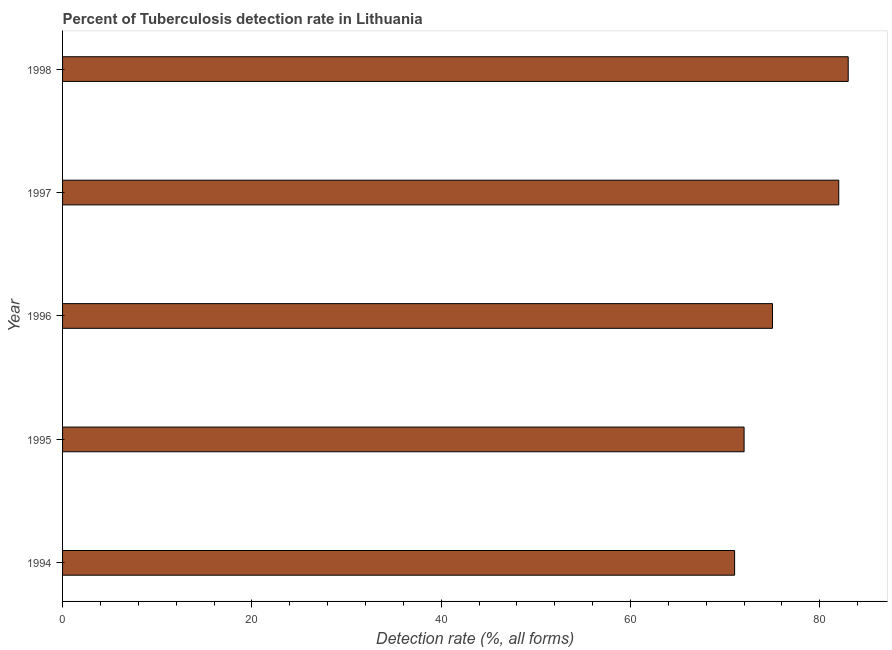Does the graph contain any zero values?
Keep it short and to the point. No. What is the title of the graph?
Your answer should be compact. Percent of Tuberculosis detection rate in Lithuania. What is the label or title of the X-axis?
Provide a succinct answer. Detection rate (%, all forms). What is the label or title of the Y-axis?
Ensure brevity in your answer.  Year. What is the detection rate of tuberculosis in 1996?
Ensure brevity in your answer.  75. Across all years, what is the minimum detection rate of tuberculosis?
Offer a terse response. 71. What is the sum of the detection rate of tuberculosis?
Make the answer very short. 383. What is the difference between the detection rate of tuberculosis in 1994 and 1996?
Your answer should be compact. -4. What is the average detection rate of tuberculosis per year?
Provide a short and direct response. 76. What is the median detection rate of tuberculosis?
Make the answer very short. 75. In how many years, is the detection rate of tuberculosis greater than 32 %?
Provide a short and direct response. 5. What is the ratio of the detection rate of tuberculosis in 1994 to that in 1998?
Your answer should be compact. 0.85. Is the detection rate of tuberculosis in 1994 less than that in 1998?
Your response must be concise. Yes. Is the difference between the detection rate of tuberculosis in 1995 and 1997 greater than the difference between any two years?
Provide a succinct answer. No. What is the difference between the highest and the second highest detection rate of tuberculosis?
Keep it short and to the point. 1. What is the difference between the highest and the lowest detection rate of tuberculosis?
Your answer should be very brief. 12. How many bars are there?
Provide a short and direct response. 5. What is the Detection rate (%, all forms) in 1994?
Make the answer very short. 71. What is the Detection rate (%, all forms) of 1996?
Offer a terse response. 75. What is the difference between the Detection rate (%, all forms) in 1994 and 1996?
Keep it short and to the point. -4. What is the difference between the Detection rate (%, all forms) in 1995 and 1996?
Your response must be concise. -3. What is the difference between the Detection rate (%, all forms) in 1995 and 1997?
Offer a terse response. -10. What is the difference between the Detection rate (%, all forms) in 1995 and 1998?
Keep it short and to the point. -11. What is the difference between the Detection rate (%, all forms) in 1996 and 1997?
Offer a very short reply. -7. What is the difference between the Detection rate (%, all forms) in 1996 and 1998?
Keep it short and to the point. -8. What is the ratio of the Detection rate (%, all forms) in 1994 to that in 1996?
Provide a short and direct response. 0.95. What is the ratio of the Detection rate (%, all forms) in 1994 to that in 1997?
Your answer should be compact. 0.87. What is the ratio of the Detection rate (%, all forms) in 1994 to that in 1998?
Provide a succinct answer. 0.85. What is the ratio of the Detection rate (%, all forms) in 1995 to that in 1997?
Provide a succinct answer. 0.88. What is the ratio of the Detection rate (%, all forms) in 1995 to that in 1998?
Your response must be concise. 0.87. What is the ratio of the Detection rate (%, all forms) in 1996 to that in 1997?
Give a very brief answer. 0.92. What is the ratio of the Detection rate (%, all forms) in 1996 to that in 1998?
Your answer should be compact. 0.9. What is the ratio of the Detection rate (%, all forms) in 1997 to that in 1998?
Give a very brief answer. 0.99. 